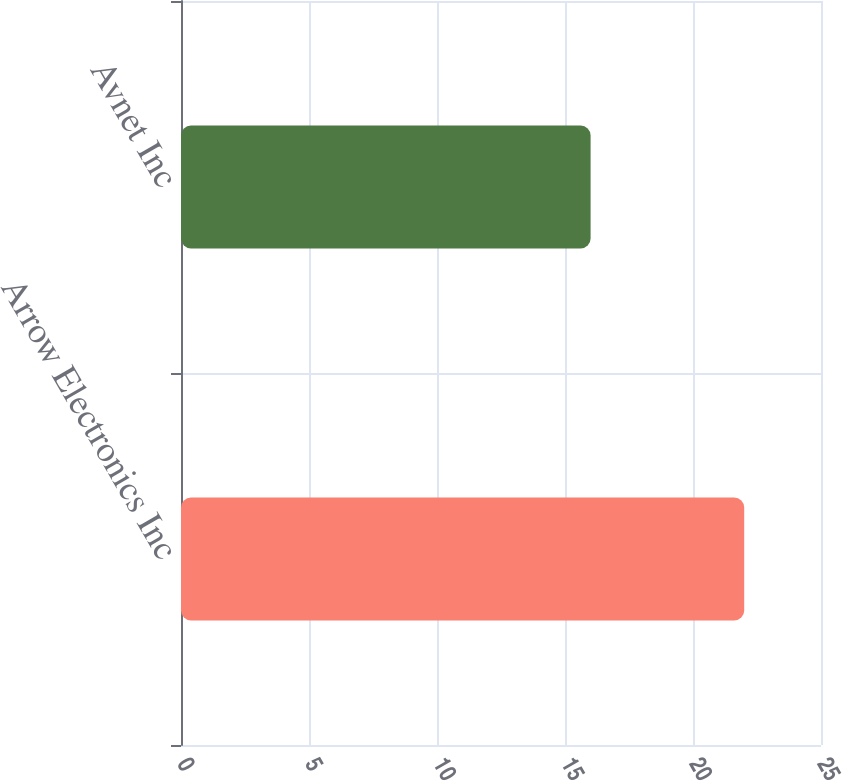Convert chart. <chart><loc_0><loc_0><loc_500><loc_500><bar_chart><fcel>Arrow Electronics Inc<fcel>Avnet Inc<nl><fcel>22<fcel>16<nl></chart> 